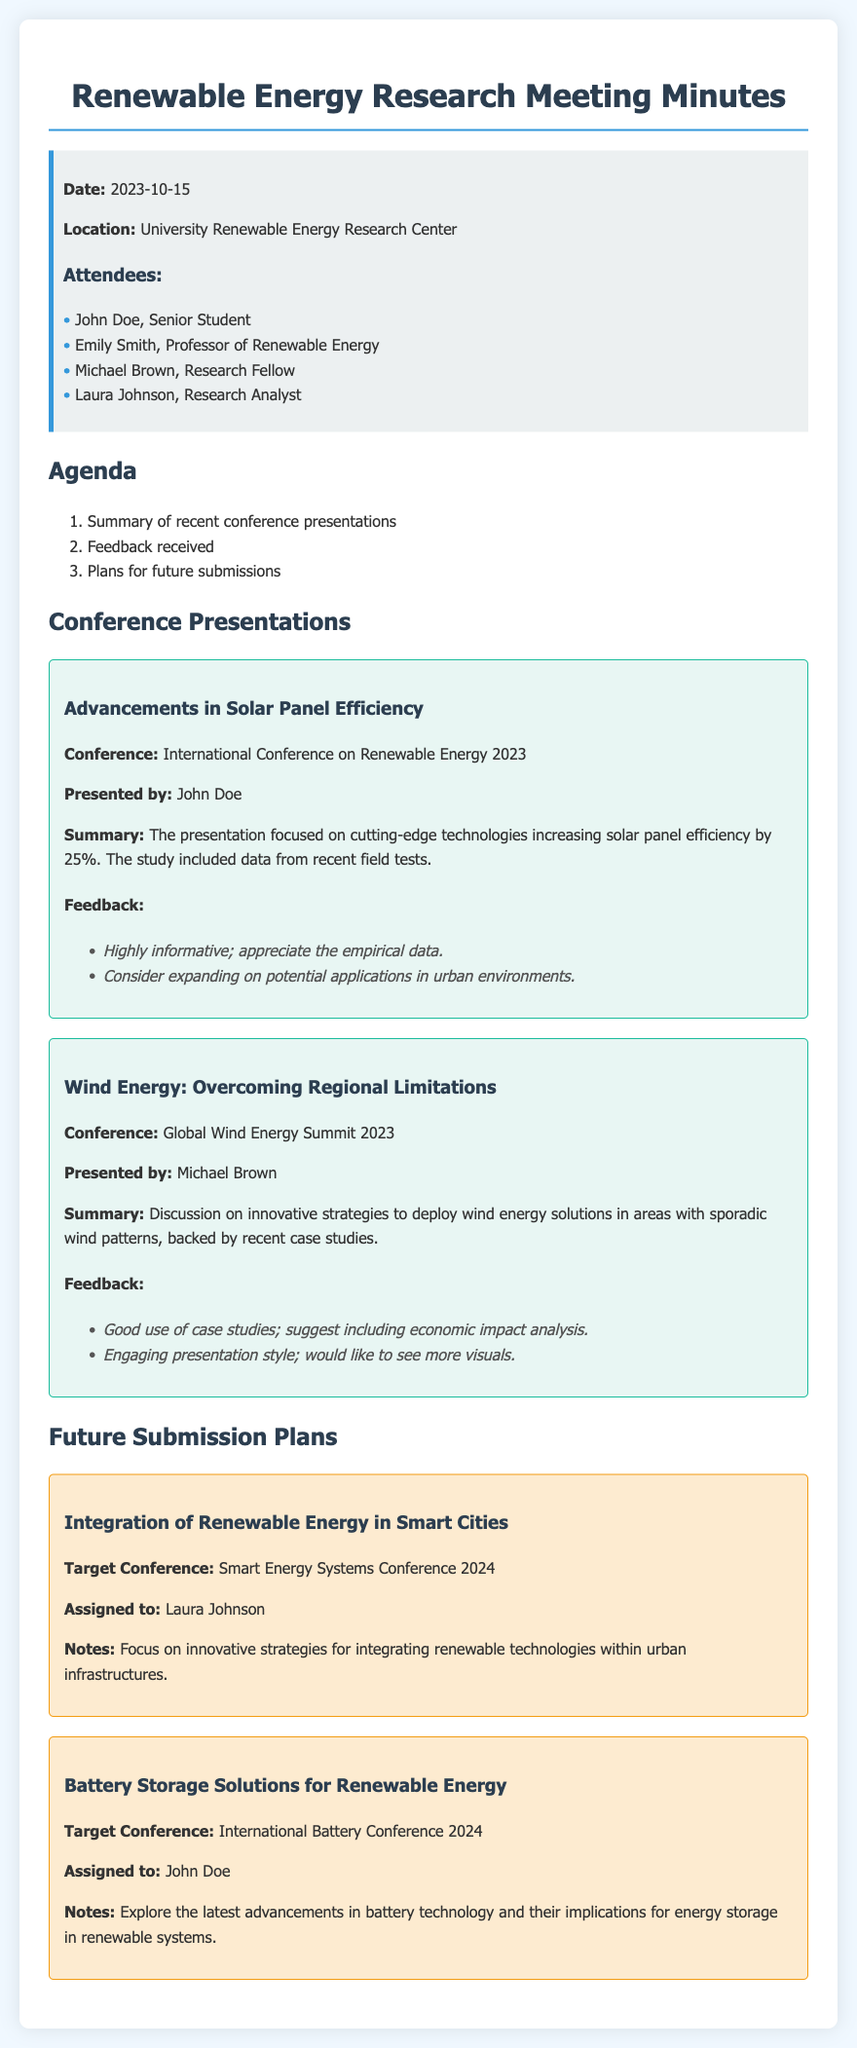What was the date of the meeting? The date of the meeting is explicitly mentioned in the document.
Answer: 2023-10-15 Who presented the topic on solar panel efficiency? The document clearly states the names of presenters for each topic.
Answer: John Doe What feedback was received for the wind energy presentation? The document lists feedback points for each presentation, particularly for the wind energy presentation.
Answer: Good use of case studies; suggest including economic impact analysis What is the target conference for the integration of renewable energy in smart cities? The document specifies the target conferences for each future submission.
Answer: Smart Energy Systems Conference 2024 How many attendees were listed in the meeting minutes? The document provides a list of attendees under the attendees section.
Answer: 4 What was one of the proposed notes for the battery storage solutions submission? Future plans section contains notes specific to each submission being planned.
Answer: Explore the latest advancements in battery technology and their implications for energy storage in renewable systems Which presenter received feedback about needing more visuals? The feedback section notes specific comments on presentation styles and content for each presenter.
Answer: Michael Brown What innovative strategies are discussed for the future submission assigned to Laura Johnson? The notes for the future submission provide insights into the focus areas for the upcoming research.
Answer: Integrating renewable technologies within urban infrastructures 